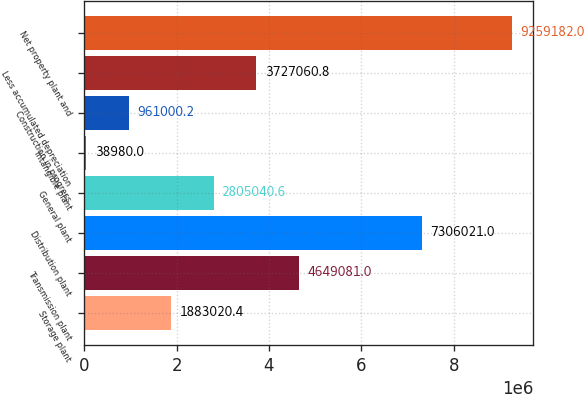Convert chart to OTSL. <chart><loc_0><loc_0><loc_500><loc_500><bar_chart><fcel>Storage plant<fcel>Transmission plant<fcel>Distribution plant<fcel>General plant<fcel>Intangible plant<fcel>Construction in progress<fcel>Less accumulated depreciation<fcel>Net property plant and<nl><fcel>1.88302e+06<fcel>4.64908e+06<fcel>7.30602e+06<fcel>2.80504e+06<fcel>38980<fcel>961000<fcel>3.72706e+06<fcel>9.25918e+06<nl></chart> 